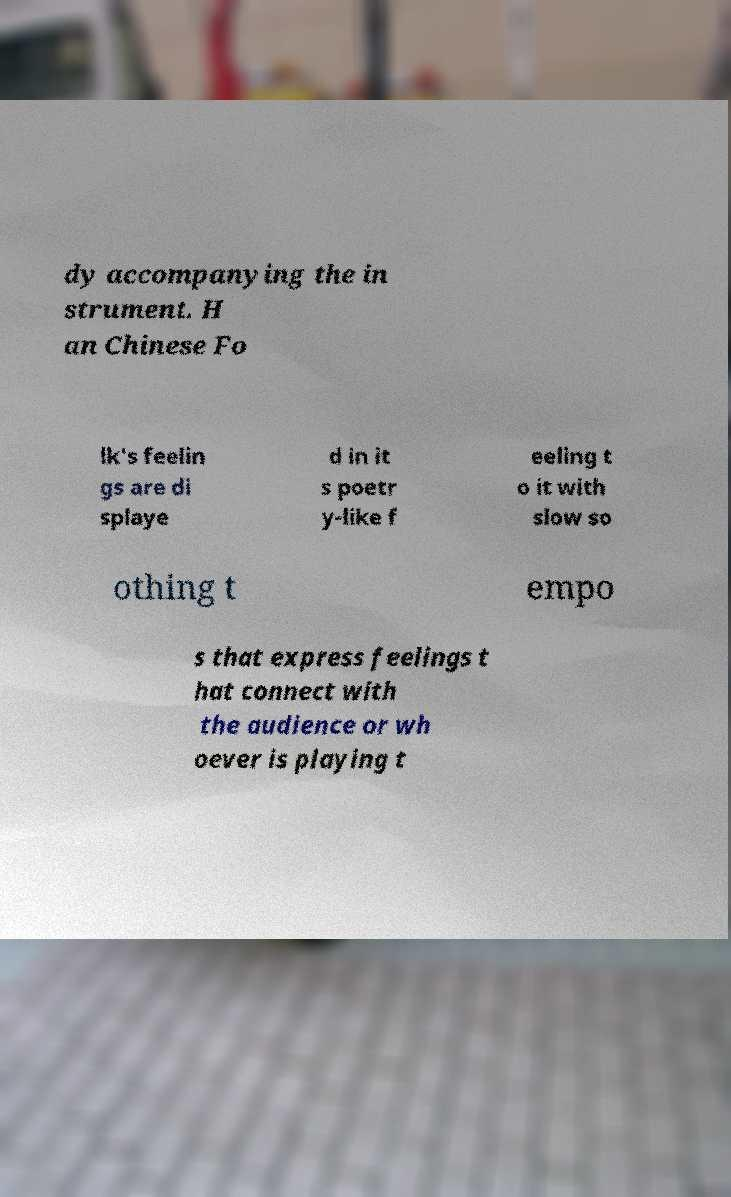I need the written content from this picture converted into text. Can you do that? dy accompanying the in strument. H an Chinese Fo lk's feelin gs are di splaye d in it s poetr y-like f eeling t o it with slow so othing t empo s that express feelings t hat connect with the audience or wh oever is playing t 